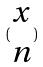<formula> <loc_0><loc_0><loc_500><loc_500>( \begin{matrix} x \\ n \end{matrix} )</formula> 